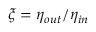Convert formula to latex. <formula><loc_0><loc_0><loc_500><loc_500>\xi = \eta _ { o u t } / \eta _ { i n }</formula> 